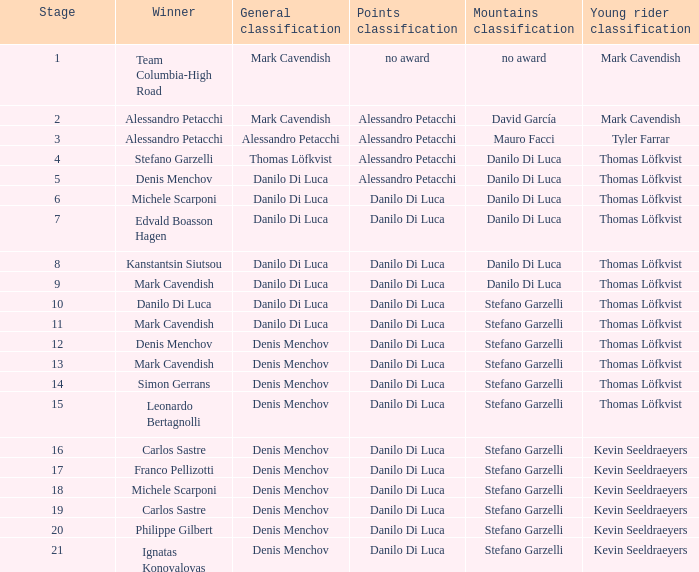When  thomas löfkvist is the general classification who is the winner? Stefano Garzelli. 